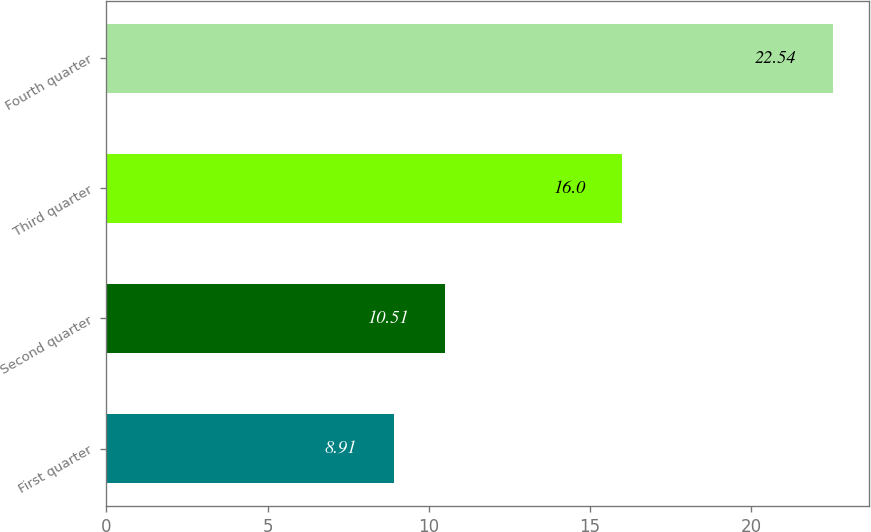<chart> <loc_0><loc_0><loc_500><loc_500><bar_chart><fcel>First quarter<fcel>Second quarter<fcel>Third quarter<fcel>Fourth quarter<nl><fcel>8.91<fcel>10.51<fcel>16<fcel>22.54<nl></chart> 